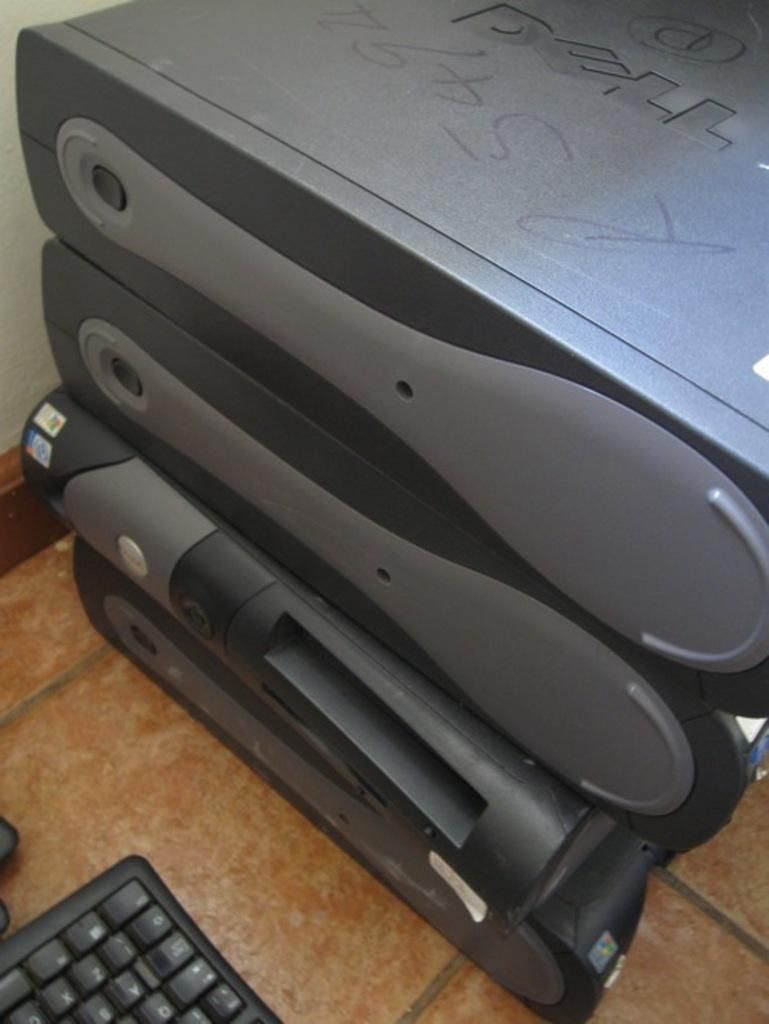<image>
Provide a brief description of the given image. Several machines stacked on top of each other with the top one saying DELL. 